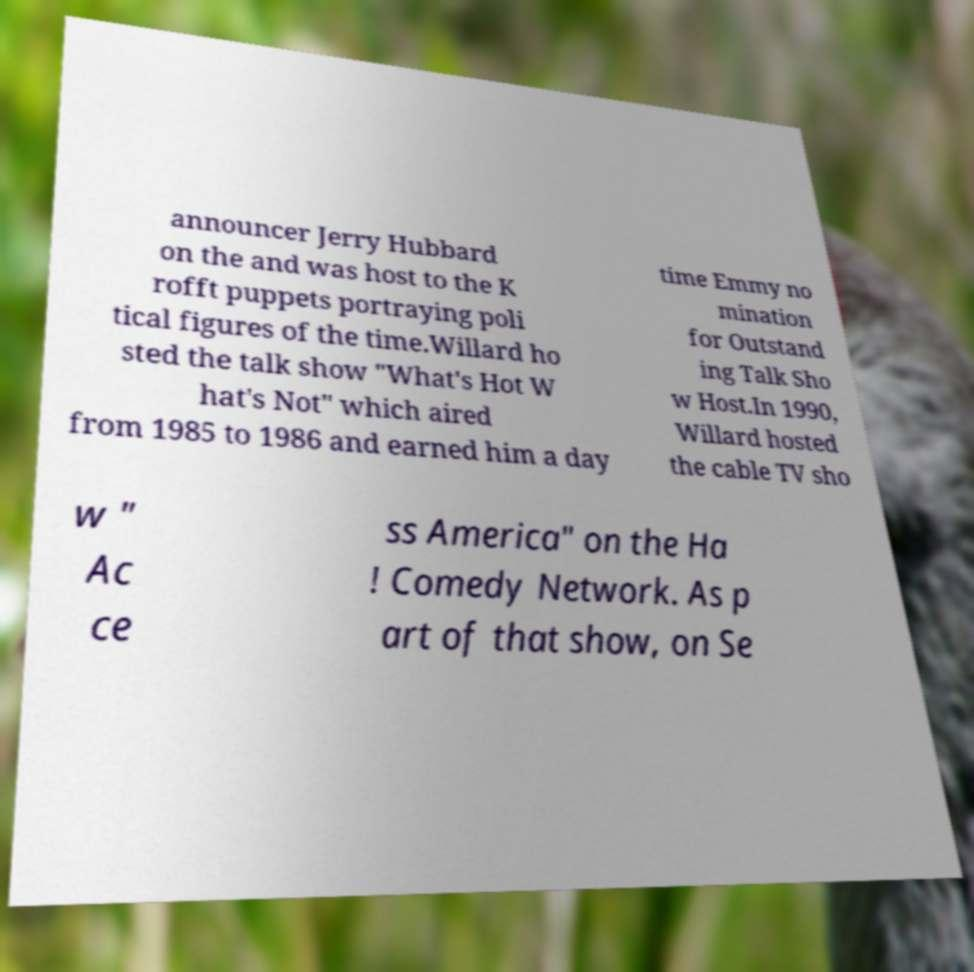There's text embedded in this image that I need extracted. Can you transcribe it verbatim? announcer Jerry Hubbard on the and was host to the K rofft puppets portraying poli tical figures of the time.Willard ho sted the talk show "What's Hot W hat's Not" which aired from 1985 to 1986 and earned him a day time Emmy no mination for Outstand ing Talk Sho w Host.In 1990, Willard hosted the cable TV sho w " Ac ce ss America" on the Ha ! Comedy Network. As p art of that show, on Se 